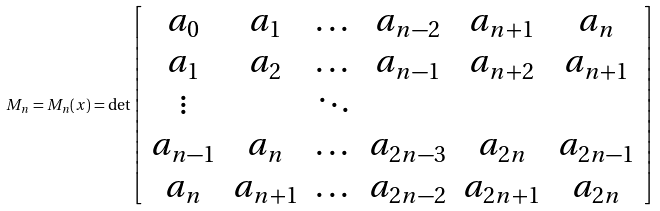Convert formula to latex. <formula><loc_0><loc_0><loc_500><loc_500>M _ { n } = M _ { n } ( x ) = \det \left [ \begin{array} { c c c c c c c } a _ { 0 } & a _ { 1 } & \dots & a _ { n - 2 } & a _ { n + 1 } & a _ { n } \\ a _ { 1 } & a _ { 2 } & \dots & a _ { n - 1 } & a _ { n + 2 } & a _ { n + 1 } \\ \vdots & & \ddots \\ a _ { n - 1 } & a _ { n } & \dots & a _ { 2 n - 3 } & a _ { 2 n } & a _ { 2 n - 1 } \\ a _ { n } & a _ { n + 1 } & \dots & a _ { 2 n - 2 } & a _ { 2 n + 1 } & a _ { 2 n } \end{array} \right ]</formula> 